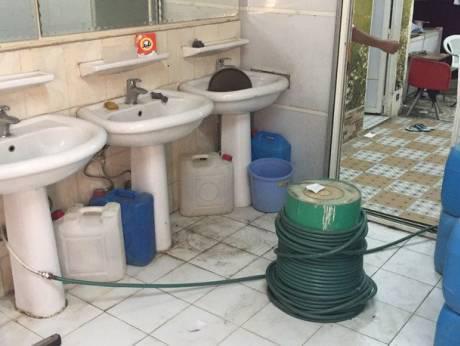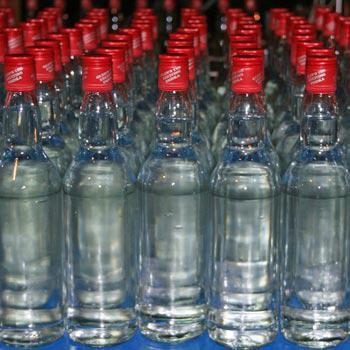The first image is the image on the left, the second image is the image on the right. Examine the images to the left and right. Is the description "The right and left images include the same number of water containers." accurate? Answer yes or no. No. The first image is the image on the left, the second image is the image on the right. For the images shown, is this caption "The left and right image contains the same number of containers filled with water." true? Answer yes or no. No. 